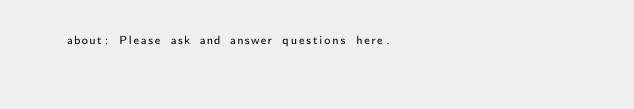Convert code to text. <code><loc_0><loc_0><loc_500><loc_500><_YAML_>    about: Please ask and answer questions here.
</code> 